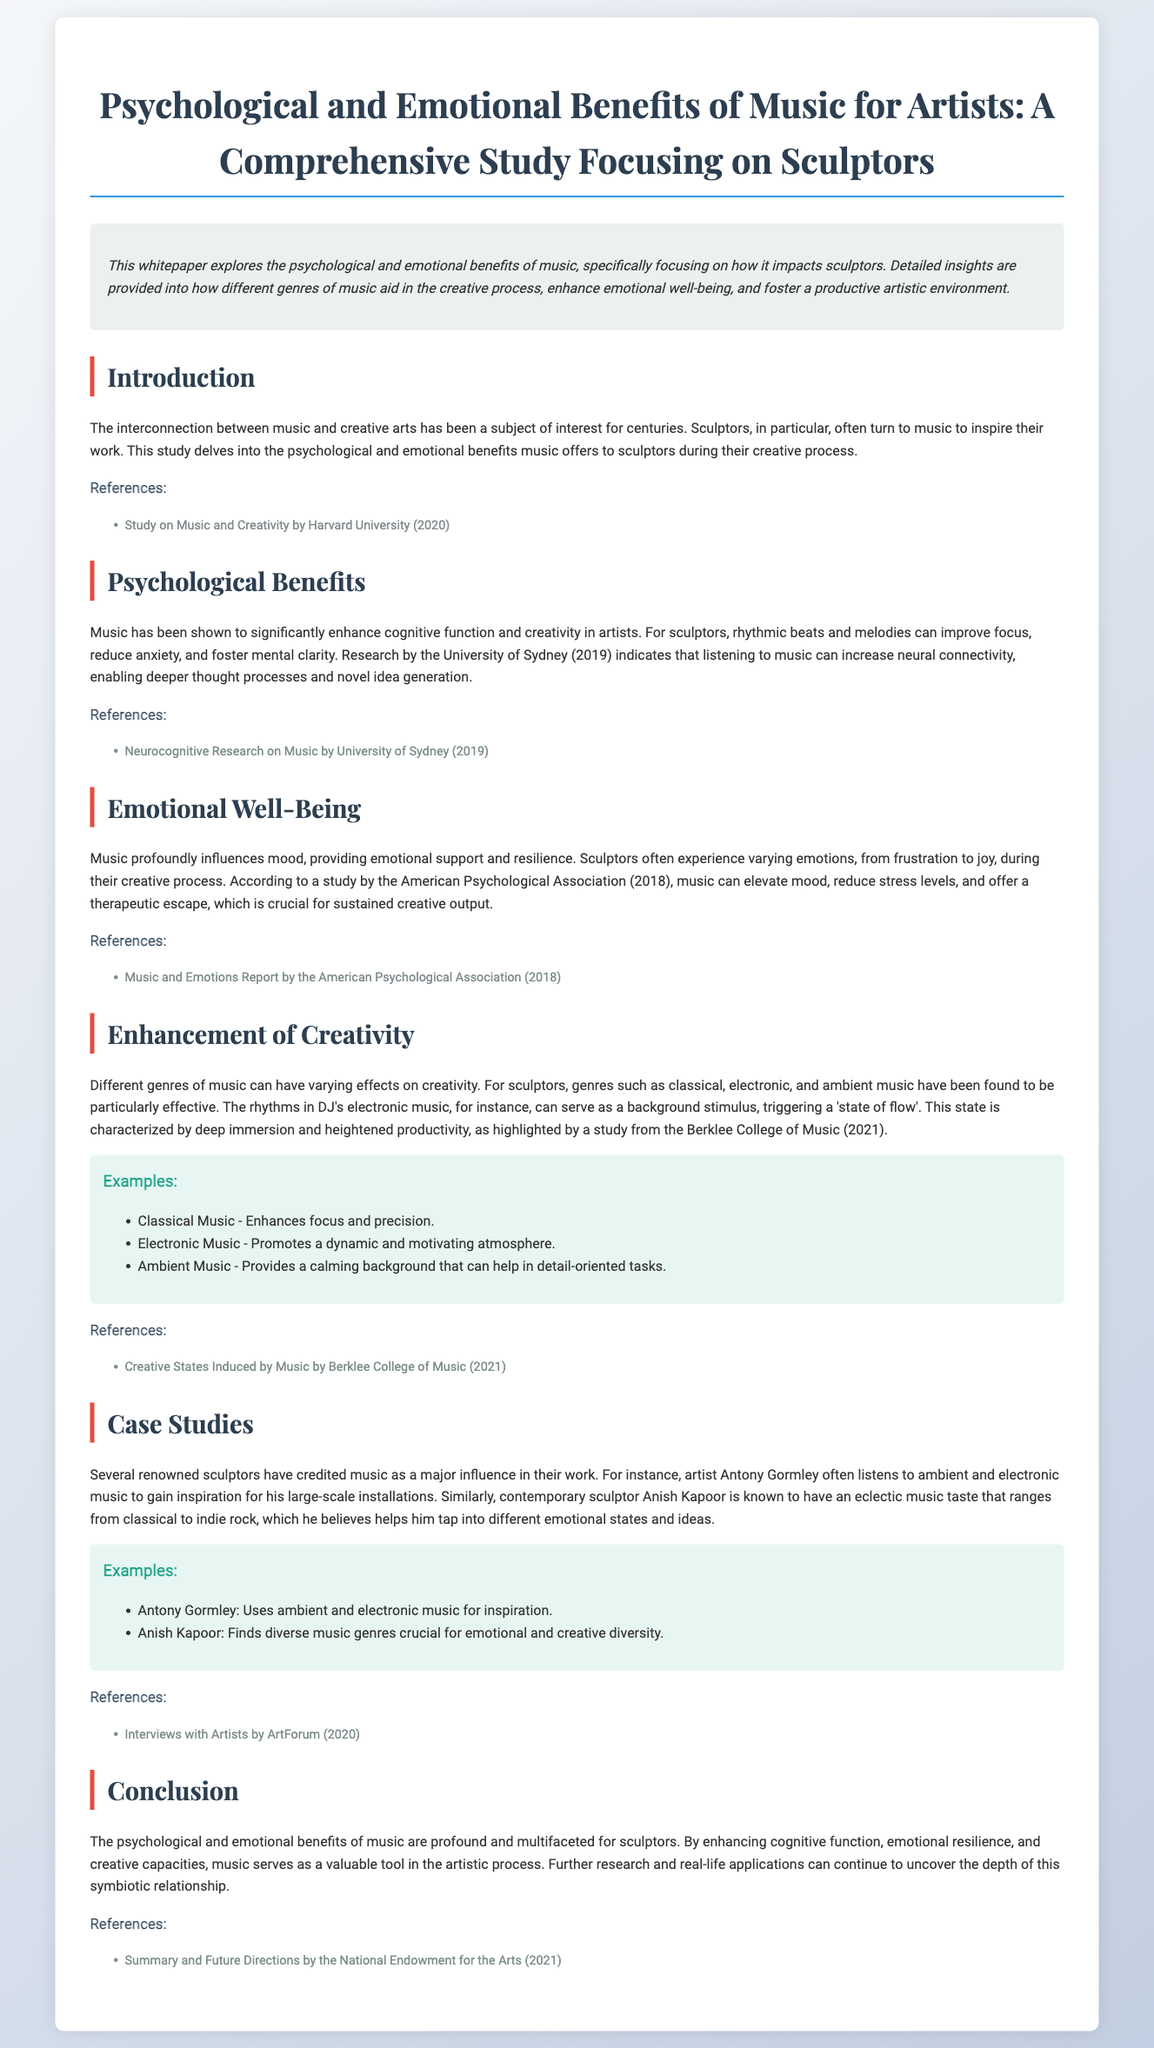What is the title of the whitepaper? The title is the opening statement that summarizes the main focus and scope of the document.
Answer: Psychological and Emotional Benefits of Music for Artists: A Comprehensive Study Focusing on Sculptors What year was the study by Harvard University published? It is mentioned in the references section of the introduction.
Answer: 2020 Which emotional state is supported by music, according to the study? The emotional state that music influences is specified in the Emotional Well-Being section.
Answer: Mood What genre of music is particularly mentioned as promoting a dynamic atmosphere? The specific genre is listed in the Enhancement of Creativity section under examples.
Answer: Electronic Music Who is a renowned sculptor that listens to ambient and electronic music? This individual's name is mentioned along with their artistic preferences in the Case Studies section.
Answer: Antony Gormley Which institution conducted research on neurocognitive effects of music? The institution is referenced in the Psychological Benefits section.
Answer: University of Sydney What is the primary focus of this whitepaper? The focus is outlined in the abstract, providing an overview of the document's content.
Answer: Psychological and emotional benefits of music for sculptors What is the emotional effect of music on sculptors according to the American Psychological Association? This effect is indicated in the Emotional Well-Being section and highlights music's impact on artists.
Answer: Reduce stress levels What type of music is proposed to enhance focus and precision for sculptors? The type is mentioned under examples in the Enhancement of Creativity section.
Answer: Classical Music What year did the Berklee College of Music publish a study about creative states induced by music? This information can be found in the references section of the Enhancement of Creativity section.
Answer: 2021 